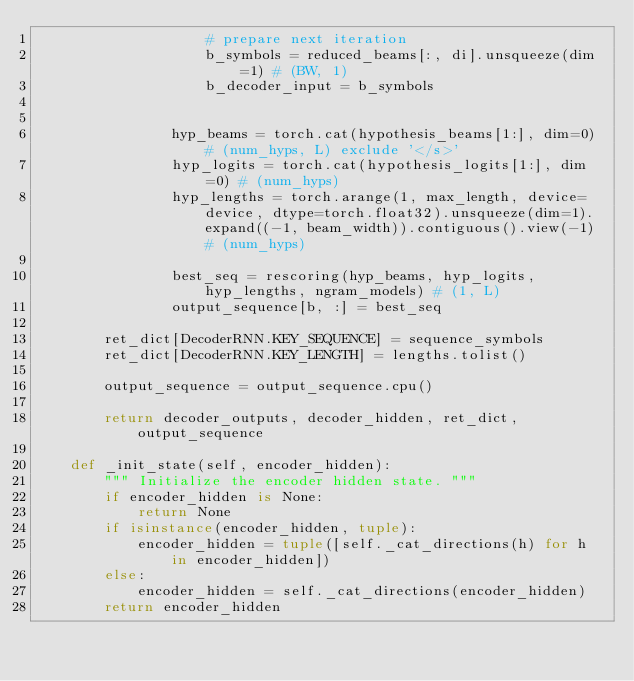<code> <loc_0><loc_0><loc_500><loc_500><_Python_>					# prepare next iteration
					b_symbols = reduced_beams[:, di].unsqueeze(dim=1) # (BW, 1)
					b_decoder_input = b_symbols


				hyp_beams = torch.cat(hypothesis_beams[1:], dim=0) # (num_hyps, L) exclude '</s>'
				hyp_logits = torch.cat(hypothesis_logits[1:], dim=0) # (num_hyps)
				hyp_lengths = torch.arange(1, max_length, device=device, dtype=torch.float32).unsqueeze(dim=1).expand((-1, beam_width)).contiguous().view(-1) # (num_hyps)

				best_seq = rescoring(hyp_beams, hyp_logits, hyp_lengths, ngram_models) # (1, L)
				output_sequence[b, :] = best_seq

		ret_dict[DecoderRNN.KEY_SEQUENCE] = sequence_symbols
		ret_dict[DecoderRNN.KEY_LENGTH] = lengths.tolist()

		output_sequence = output_sequence.cpu()

		return decoder_outputs, decoder_hidden, ret_dict, output_sequence

	def _init_state(self, encoder_hidden):
		""" Initialize the encoder hidden state. """
		if encoder_hidden is None:
			return None
		if isinstance(encoder_hidden, tuple):
			encoder_hidden = tuple([self._cat_directions(h) for h in encoder_hidden])
		else:
			encoder_hidden = self._cat_directions(encoder_hidden)
		return encoder_hidden
</code> 